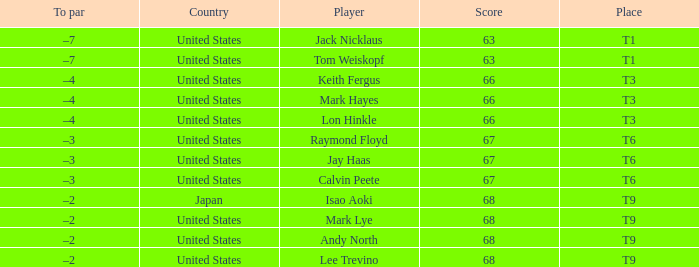What is Place, when Country is "United States", and when Player is "Lee Trevino"? T9. 